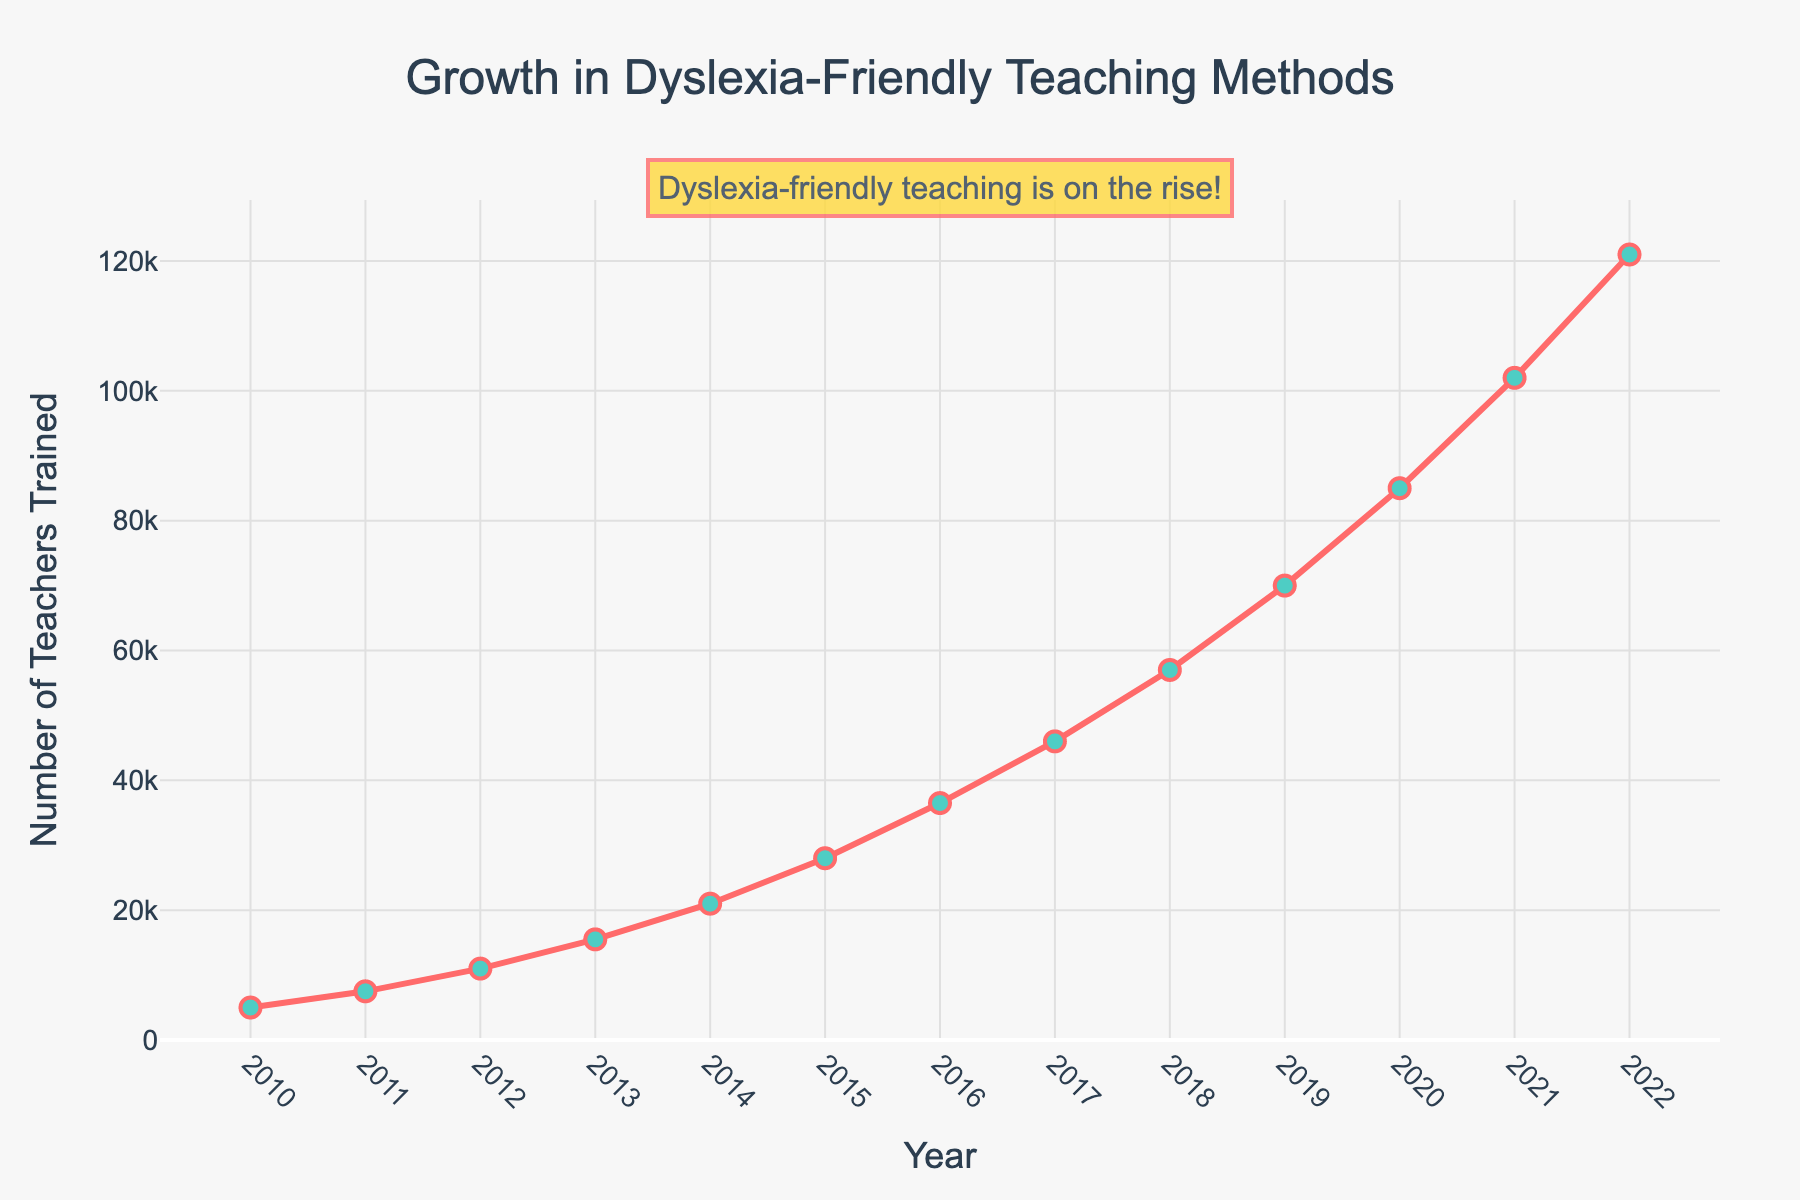What is the total number of teachers trained by 2022? Sum the number of teachers trained each year from 2010 to 2022. Adding all these values together: 5000 + 7500 + 11000 + 15500 + 21000 + 28000 + 36500 + 46000 + 57000 + 70000 + 85000 + 102000 + 121000 = 558000
Answer: 558000 What was the average number of teachers trained per year from 2010 to 2022? Sum the number of teachers trained each year from 2010 to 2022 and divide by the number of years (2022-2010 + 1 = 13 years). The total is 558000, so the average is 558000 / 13 ≈ 42923.08
Answer: 42923.08 Which year saw the greatest increase in teachers trained compared to the previous year? Calculate the year-over-year differences and find the maximum: 2500 (2011), 3500 (2012), 4500 (2013), 5500 (2014), 7000 (2015), 8500 (2016), 9500 (2017), 11000 (2018), 13000 (2019), 15000 (2020), 17000 (2021), 19000 (2022). The greatest increase is from 2021 to 2022 of 19000
Answer: 2022 How many teachers were trained in 2015 compared to 2012? Compare the numbers for 2015 (28000) and 2012 (11000). To find the difference, subtract 11000 from 28000, yielding 17000 more teachers in 2015
Answer: 17000 By what factor did the number of teachers trained in 2022 increase compared to 2010? Divide the number of teachers trained in 2022 (121000) by the number in 2010 (5000) to get the factor: 121000 / 5000 = 24.2
Answer: 24.2 What is the trend in the growth of teachers trained between 2010 and 2022? Observe that the number of teachers trained increases consistently over the years without any dips. This shows a steady upward trend in training.
Answer: Steady upward In which year did the number of teachers trained first exceed 50000? Identify the first year where the number of trained teachers is greater than 50000. This is 2018 with 57000 teachers.
Answer: 2018 What is the difference in the number of teachers trained between 2018 and 2020? Subtract the number of teachers trained in 2018 (57000) from the number in 2020 (85000): 85000 - 57000 = 28000
Answer: 28000 How does the color scheme emphasize the data trend? The chart uses a red line with green markers. The heavy contrast between these colors draws attention to the increasing trend lines and significant data points.
Answer: Emphasizes growth through contrasting colors How many fewer teachers were trained in 2013 compared to 2016? Subtract the number of teachers trained in 2013 (15500) from the number in 2016 (36500): 36500 - 15500 = 21000 fewer teachers in 2013.
Answer: 21000 fewer 